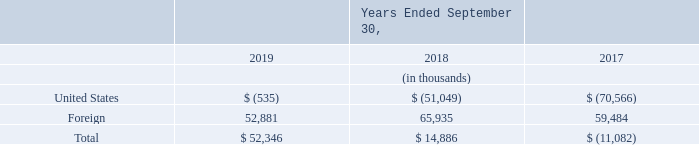NOTE 13—INCOME TAXES
On December 22, 2017, the U.S. government enacted the Tax Act, which includes provisions for Global Intangible Low-Tax Income (GILTI) under which taxes on foreign income are imposed on the excess of a deemed return on tangible assets of foreign subsidiaries. Consistent with accounting guidance, we have elected to account for the tax on GILTI as a period cost and thus have not adjusted any net deferred tax assets of our foreign subsidiaries in connection with the Tax Act.
Due to the complexity of the Tax Act, the Securities and Exchange Commission issued guidance in SAB 118 which clarified the accounting for income taxes under ASC 740 if certain information was not yet available, prepared or analyzed in reasonable detail to complete the accounting for income tax effects of the Tax Act. SAB 118 provided for a measurement period of up to one year after the enactment of the Tax Act, during which time the required analyses and accounting must be completed. During fiscal year 2018, we recorded provisional amounts for the income tax effects of the changes in tax law and tax rates, as reasonable estimates were determined by management during this period. These amounts did not change in fiscal year 2019.
The SAB 118 measurement period ended on December 22, 2018. Although we no longer consider these amounts to be provisional, the determination of the Tax Act’s income tax effects may change following future legislation or further interpretation of the Tax Act based on the publication of recently proposed U.S. Treasury regulations and guidance from the Internal Revenue Service and state tax authorities.
Income (loss) from continuing operations before income taxes includes the following components (in thousands):
The Securities and Exchange Commission issued guidance in SAB 118 provided what form of clarification? The accounting for income taxes under asc 740 if certain information was not yet available, prepared or analyzed in reasonable detail to complete the accounting for income tax effects of the tax act. How may the determination of the Tax Act's income tax effects change? Following future legislation or further interpretation of the tax act based on the publication of recently proposed u.s. treasury regulations and guidance from the internal revenue service and state tax authorities. What are the components recorded under income (loss) from continuing operations before income taxes? United states, foreign. In which year was the amount under Foreign the smallest? 52,881<59,484<65,935
Answer: 2019. What is the change in the amount under Foreign in 2019 from 2018?
Answer scale should be: thousand. 52,881-65,935
Answer: -13054. What is the percentage change in the amount under Foreign in 2019 from 2018?
Answer scale should be: percent. (52,881-65,935)/65,935
Answer: -19.8. 